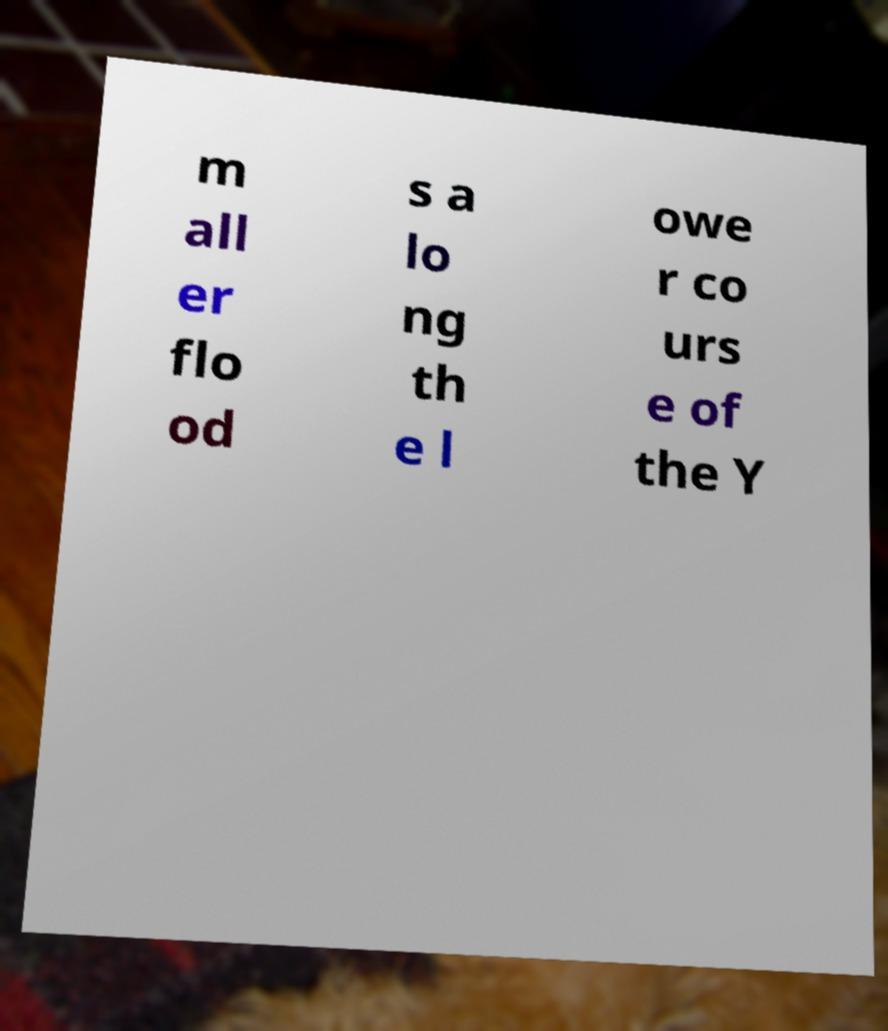Could you assist in decoding the text presented in this image and type it out clearly? m all er flo od s a lo ng th e l owe r co urs e of the Y 